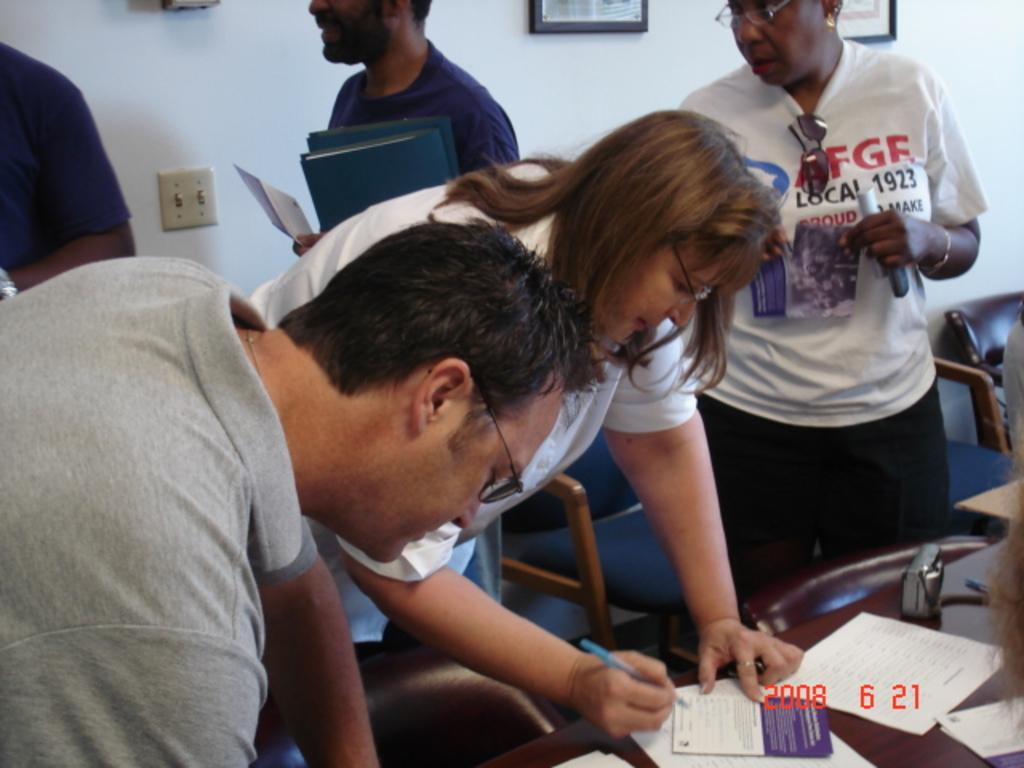Who or what can be seen in the image? There are people in the image. What type of furniture is present in the image? There are chairs in the image. What is the color of the wall in the image? There is a white color wall in the image. What type of decorative items can be seen in the image? There are photo frames in the image. What is the main piece of furniture in the image? There is a table in the image. What is placed on the table in the image? Papers are present on the table. Can you see any crayons being used for an activity in the image? There is no mention of crayons or any activity involving crayons in the image. Is the seashore visible in the image? The image does not depict a seashore; it features people, chairs, a white wall, photo frames, a table, and papers. 